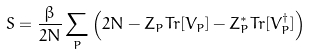<formula> <loc_0><loc_0><loc_500><loc_500>S = \frac { \beta } { 2 N } \sum _ { P } \left ( 2 N - Z _ { P } T r [ V _ { P } ] - Z ^ { \ast } _ { P } T r [ V ^ { \dagger } _ { P } ] \right )</formula> 